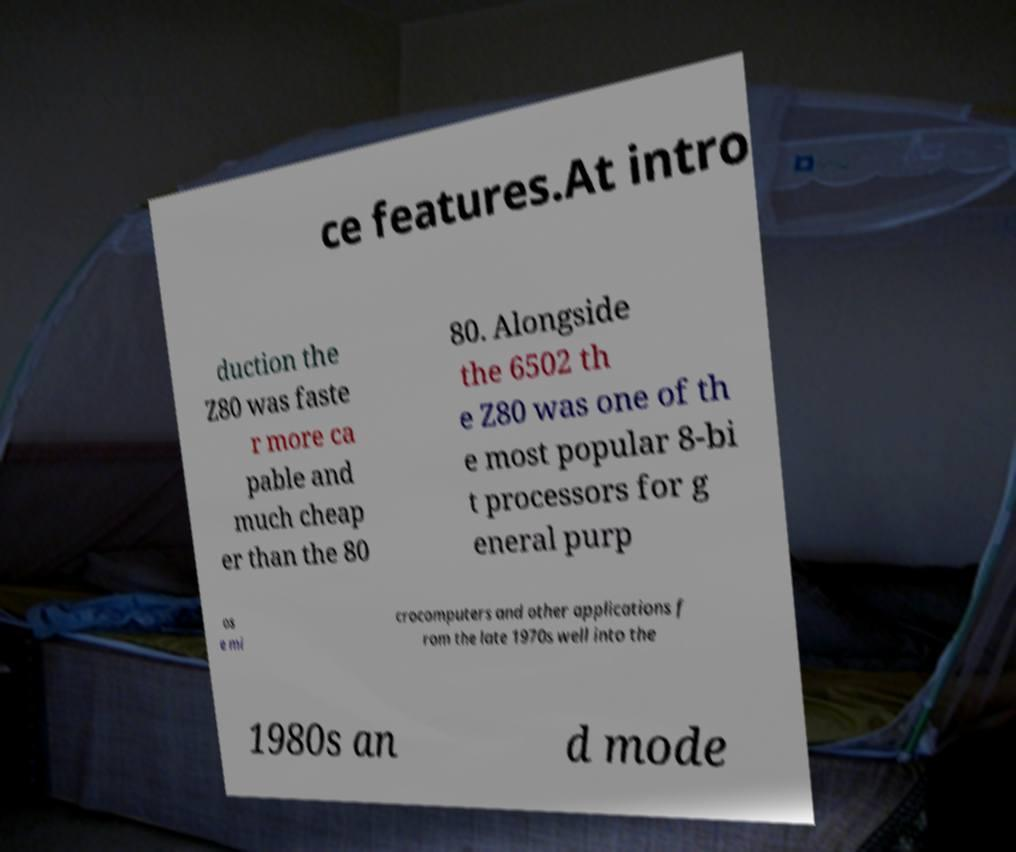Could you assist in decoding the text presented in this image and type it out clearly? ce features.At intro duction the Z80 was faste r more ca pable and much cheap er than the 80 80. Alongside the 6502 th e Z80 was one of th e most popular 8-bi t processors for g eneral purp os e mi crocomputers and other applications f rom the late 1970s well into the 1980s an d mode 